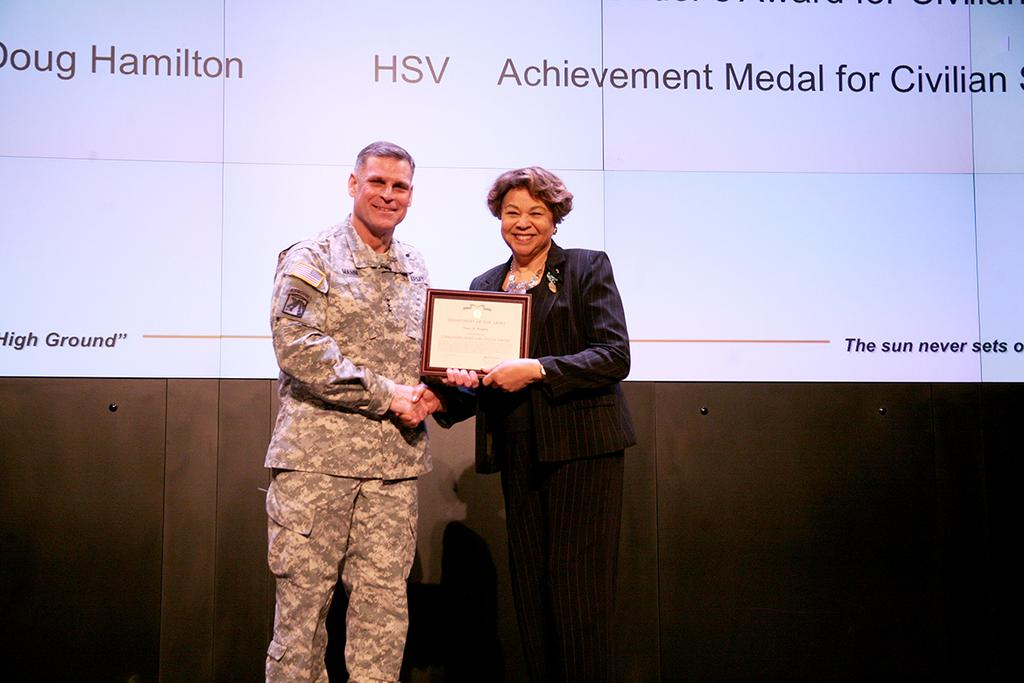What is the main object in the image? There is a screen in the image. What other object can be seen in the image? There is a photo frame in the image. How many people are present in the image? There are two people standing in the image. What is the woman wearing? The woman is wearing a black color jacket. What is the man wearing? The man is wearing a military dress. What type of lumber is the man using to act with his pet in the image? There is no lumber, act, or pet present in the image. 